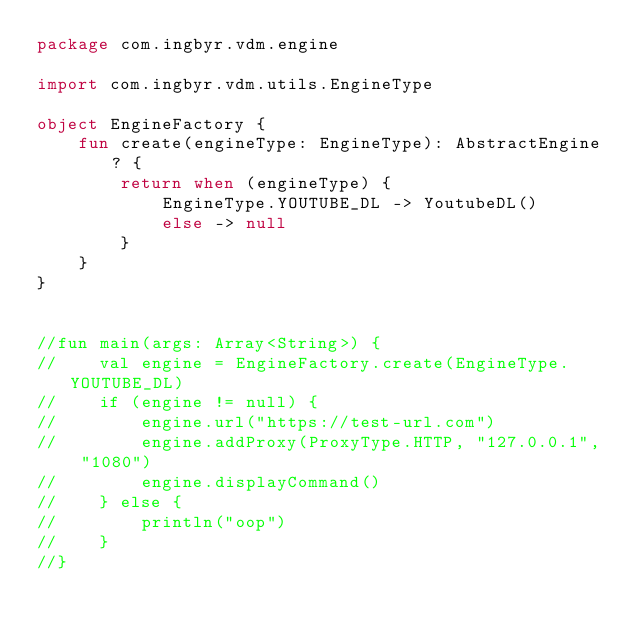Convert code to text. <code><loc_0><loc_0><loc_500><loc_500><_Kotlin_>package com.ingbyr.vdm.engine

import com.ingbyr.vdm.utils.EngineType

object EngineFactory {
    fun create(engineType: EngineType): AbstractEngine? {
        return when (engineType) {
            EngineType.YOUTUBE_DL -> YoutubeDL()
            else -> null
        }
    }
}


//fun main(args: Array<String>) {
//    val engine = EngineFactory.create(EngineType.YOUTUBE_DL)
//    if (engine != null) {
//        engine.url("https://test-url.com")
//        engine.addProxy(ProxyType.HTTP, "127.0.0.1", "1080")
//        engine.displayCommand()
//    } else {
//        println("oop")
//    }
//}</code> 